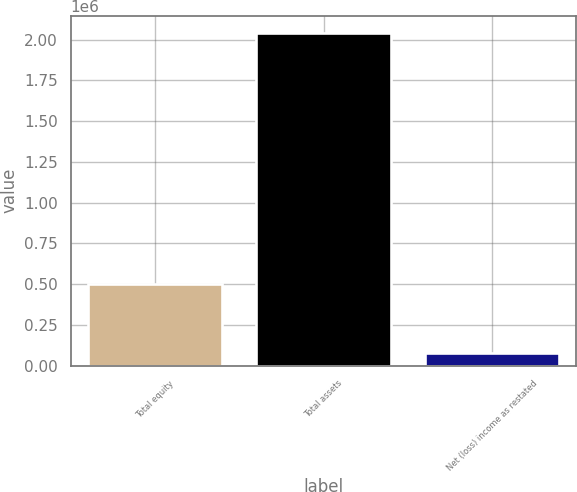<chart> <loc_0><loc_0><loc_500><loc_500><bar_chart><fcel>Total equity<fcel>Total assets<fcel>Net (loss) income as restated<nl><fcel>501677<fcel>2.0438e+06<fcel>75111<nl></chart> 